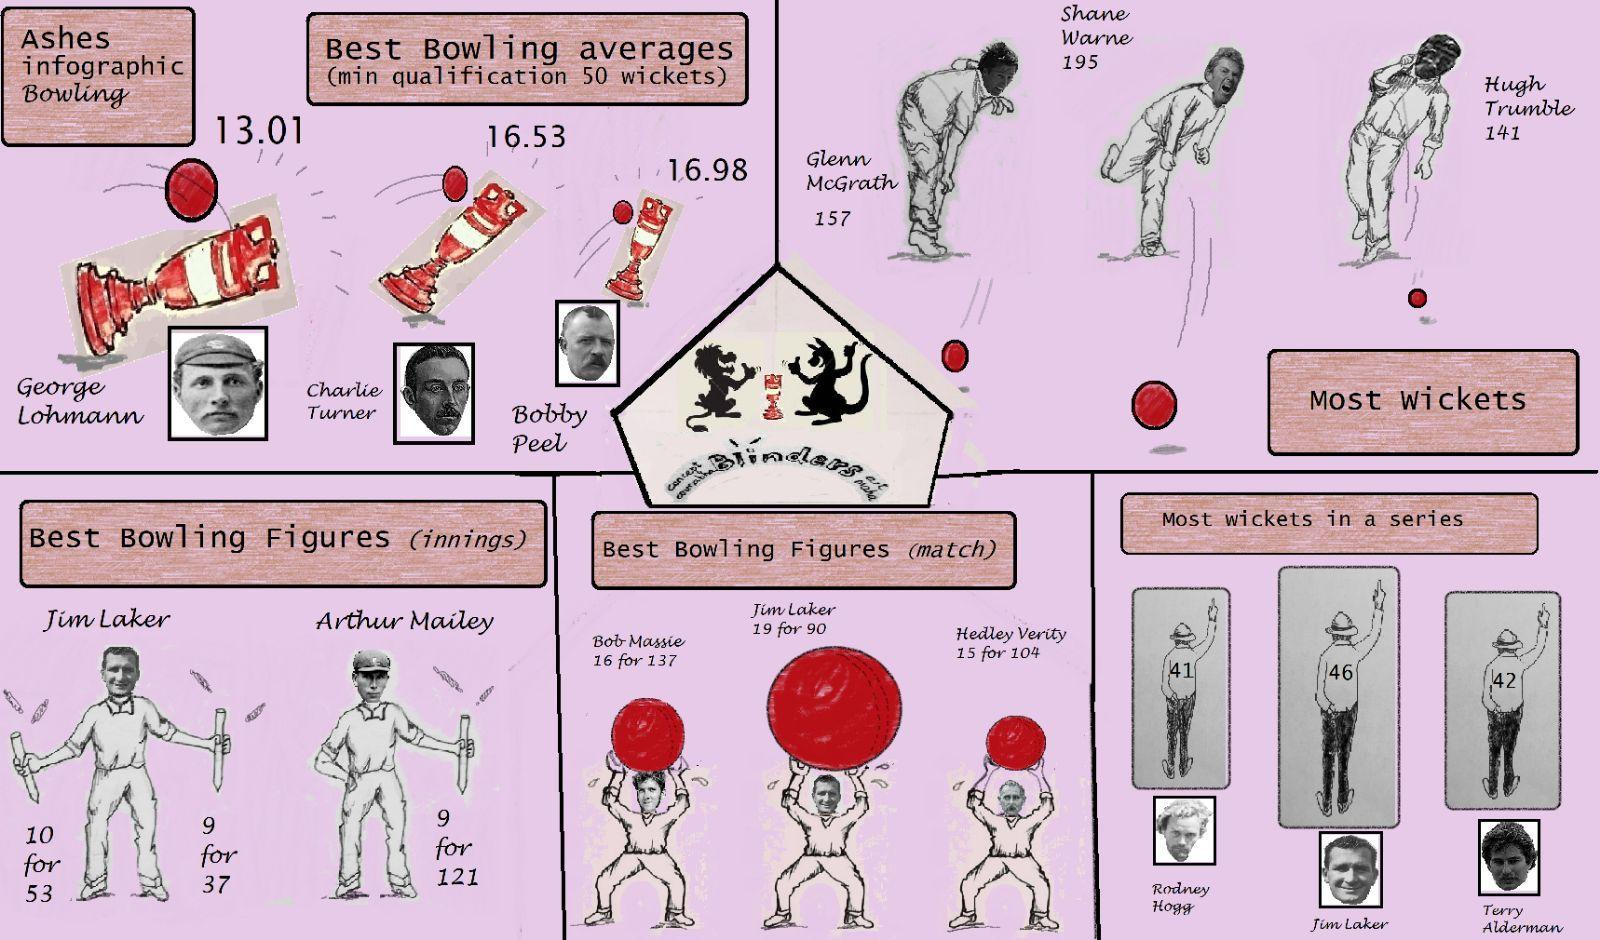Which player took the highest number of wickets?
Answer the question with a short phrase. Shane Warne Which player had the best match bowling figures and most wickets in a series ? Jim Laker Who scored the second best bowling average in Ashes? Charlie Turner 